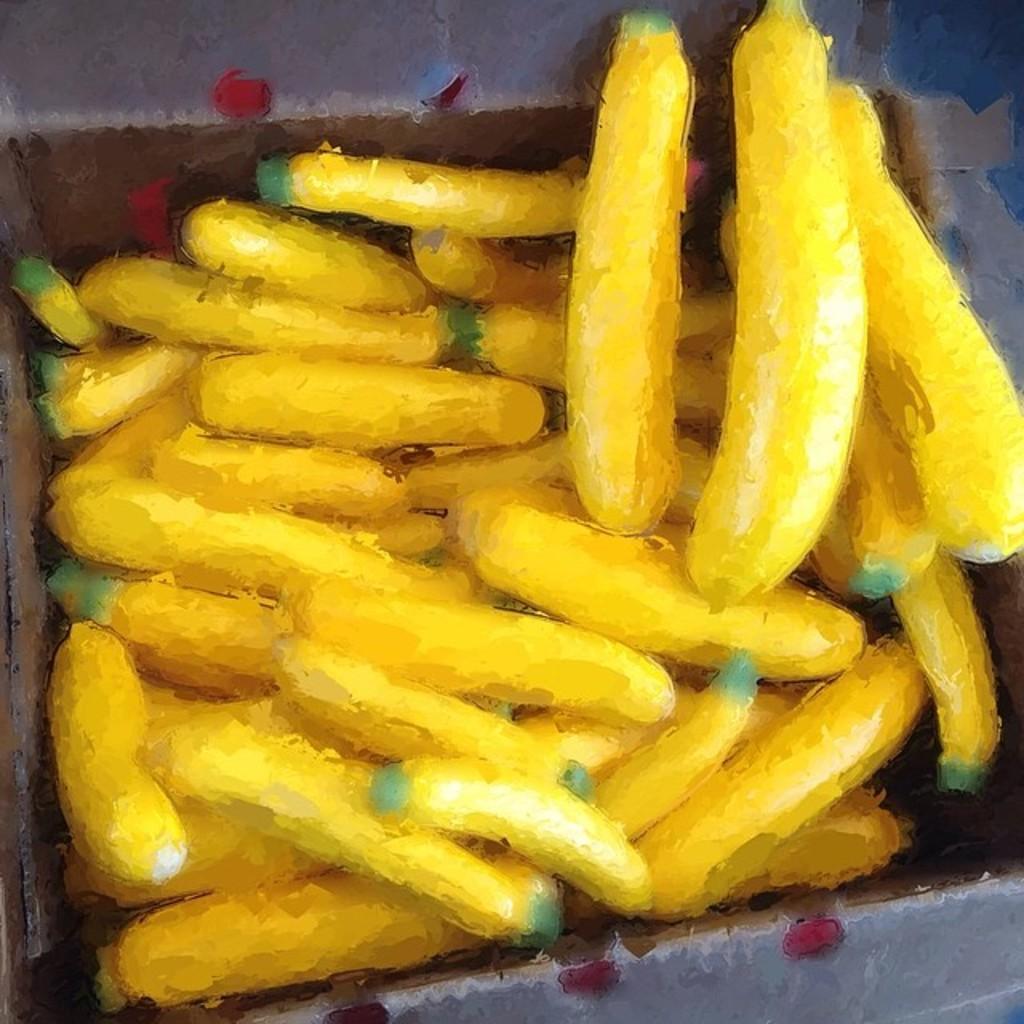Describe this image in one or two sentences. In this image we can see a painting of bananas. 